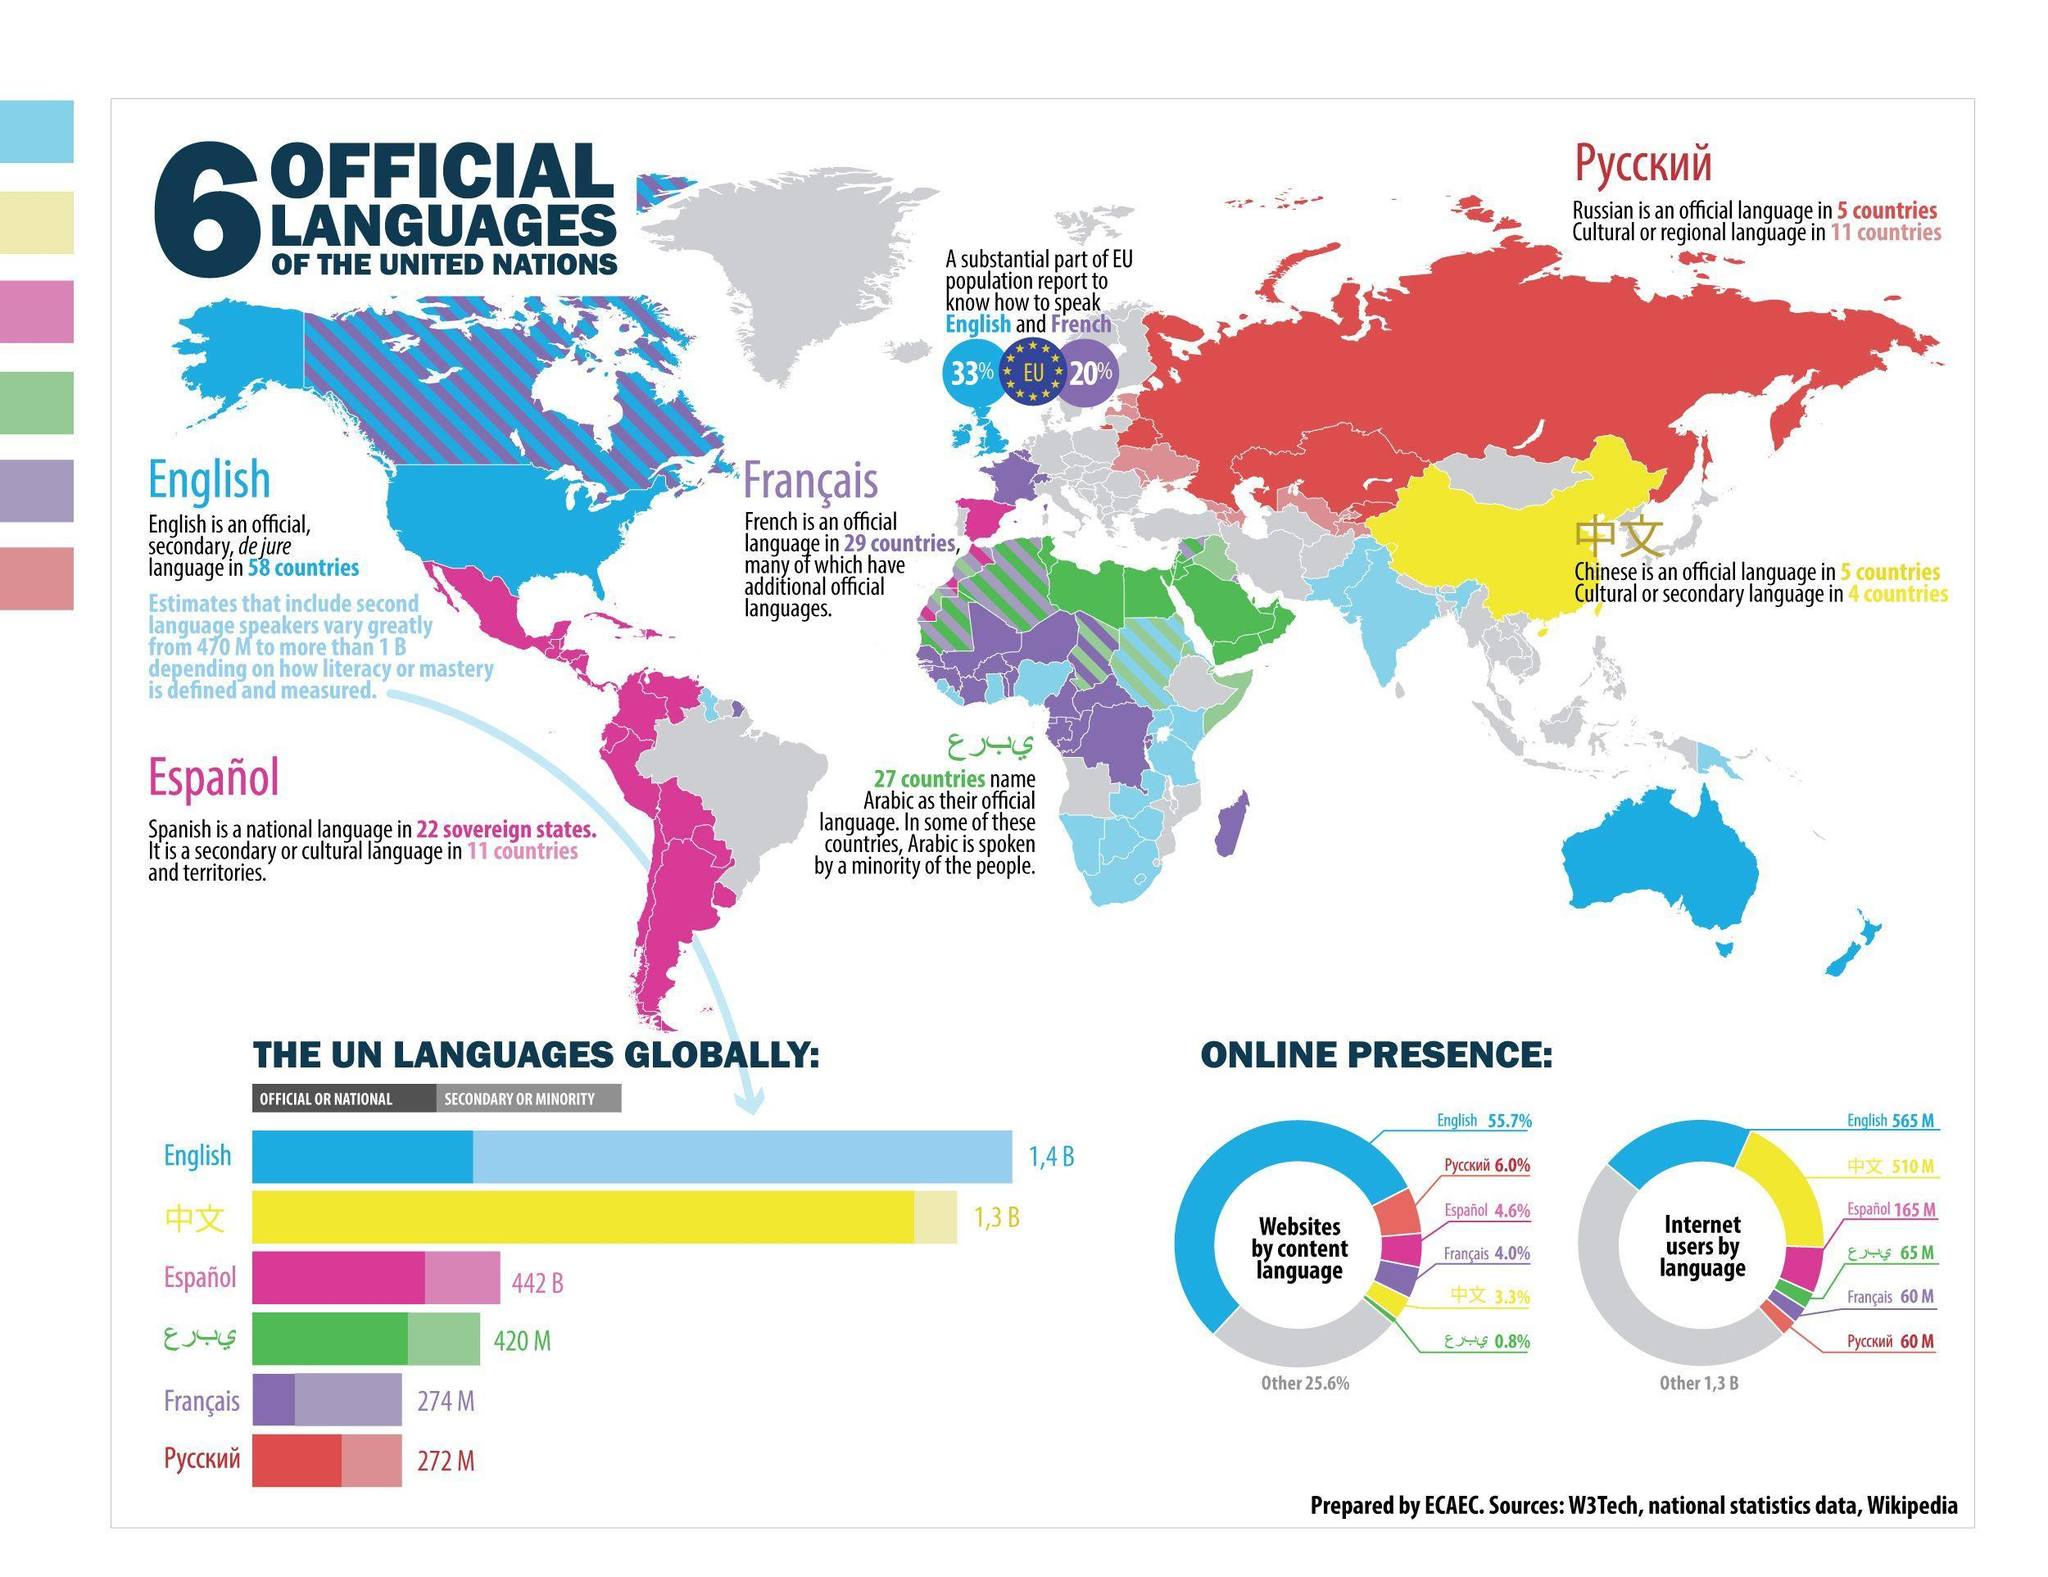Which two languages are used as official languages in 5 countries?
Answer the question with a short phrase. Chinese, Russian How much more of EU population speak in English than in French? 13% Which language is the most spoken as primary language? Chinese What percentage of websites use Spanish content? 4.6% What is the difference in count of English speakers and Chinese speakers ? 0.1 B Which is the world's second most spoken language ? French Which two languages  are used as a secondary language in 11 countries? Spanish, Russian What is the number of internet users that are Russians ? 60 M What is the percentage of websites using Arabic language ? 0.8% Which language is the most spoken as secondary language? English 